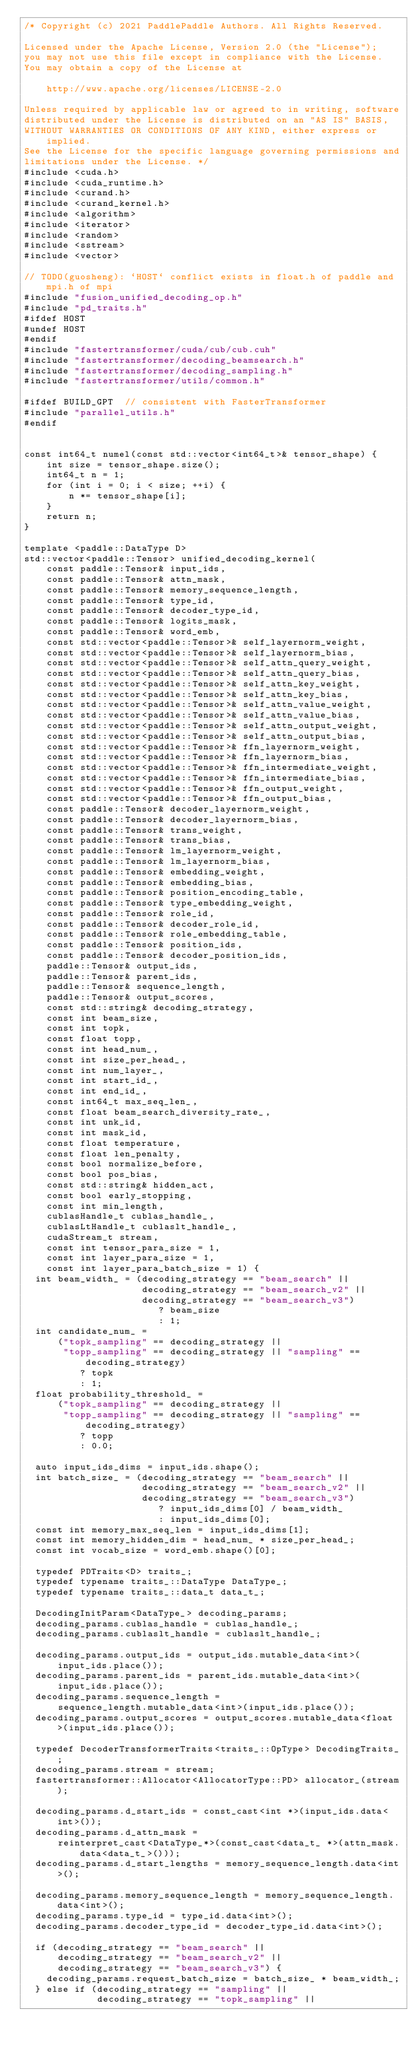<code> <loc_0><loc_0><loc_500><loc_500><_Cuda_>/* Copyright (c) 2021 PaddlePaddle Authors. All Rights Reserved.

Licensed under the Apache License, Version 2.0 (the "License");
you may not use this file except in compliance with the License.
You may obtain a copy of the License at

    http://www.apache.org/licenses/LICENSE-2.0

Unless required by applicable law or agreed to in writing, software
distributed under the License is distributed on an "AS IS" BASIS,
WITHOUT WARRANTIES OR CONDITIONS OF ANY KIND, either express or implied.
See the License for the specific language governing permissions and
limitations under the License. */
#include <cuda.h>
#include <cuda_runtime.h>
#include <curand.h>
#include <curand_kernel.h>
#include <algorithm>
#include <iterator>
#include <random>
#include <sstream>
#include <vector>

// TODO(guosheng): `HOST` conflict exists in float.h of paddle and mpi.h of mpi
#include "fusion_unified_decoding_op.h"
#include "pd_traits.h"
#ifdef HOST
#undef HOST
#endif
#include "fastertransformer/cuda/cub/cub.cuh"
#include "fastertransformer/decoding_beamsearch.h"
#include "fastertransformer/decoding_sampling.h"
#include "fastertransformer/utils/common.h"

#ifdef BUILD_GPT  // consistent with FasterTransformer
#include "parallel_utils.h"
#endif


const int64_t numel(const std::vector<int64_t>& tensor_shape) {
    int size = tensor_shape.size();
    int64_t n = 1;
    for (int i = 0; i < size; ++i) {
        n *= tensor_shape[i];
    }
    return n;
}

template <paddle::DataType D>
std::vector<paddle::Tensor> unified_decoding_kernel(
    const paddle::Tensor& input_ids,
    const paddle::Tensor& attn_mask,
    const paddle::Tensor& memory_sequence_length,
    const paddle::Tensor& type_id,
    const paddle::Tensor& decoder_type_id,
    const paddle::Tensor& logits_mask,
    const paddle::Tensor& word_emb,
    const std::vector<paddle::Tensor>& self_layernorm_weight,
    const std::vector<paddle::Tensor>& self_layernorm_bias,
    const std::vector<paddle::Tensor>& self_attn_query_weight,
    const std::vector<paddle::Tensor>& self_attn_query_bias,
    const std::vector<paddle::Tensor>& self_attn_key_weight,
    const std::vector<paddle::Tensor>& self_attn_key_bias,
    const std::vector<paddle::Tensor>& self_attn_value_weight,
    const std::vector<paddle::Tensor>& self_attn_value_bias,
    const std::vector<paddle::Tensor>& self_attn_output_weight,
    const std::vector<paddle::Tensor>& self_attn_output_bias,
    const std::vector<paddle::Tensor>& ffn_layernorm_weight,
    const std::vector<paddle::Tensor>& ffn_layernorm_bias,
    const std::vector<paddle::Tensor>& ffn_intermediate_weight,
    const std::vector<paddle::Tensor>& ffn_intermediate_bias,
    const std::vector<paddle::Tensor>& ffn_output_weight,
    const std::vector<paddle::Tensor>& ffn_output_bias,
    const paddle::Tensor& decoder_layernorm_weight,
    const paddle::Tensor& decoder_layernorm_bias,
    const paddle::Tensor& trans_weight,
    const paddle::Tensor& trans_bias,
    const paddle::Tensor& lm_layernorm_weight,
    const paddle::Tensor& lm_layernorm_bias,
    const paddle::Tensor& embedding_weight,
    const paddle::Tensor& embedding_bias,
    const paddle::Tensor& position_encoding_table,
    const paddle::Tensor& type_embedding_weight,
    const paddle::Tensor& role_id,
    const paddle::Tensor& decoder_role_id,
    const paddle::Tensor& role_embedding_table,
    const paddle::Tensor& position_ids,
    const paddle::Tensor& decoder_position_ids,
    paddle::Tensor& output_ids,
    paddle::Tensor& parent_ids,
    paddle::Tensor& sequence_length,
    paddle::Tensor& output_scores,
    const std::string& decoding_strategy,
    const int beam_size,
    const int topk,
    const float topp,
    const int head_num_,
    const int size_per_head_,
    const int num_layer_,
    const int start_id_,
    const int end_id_,
    const int64_t max_seq_len_,
    const float beam_search_diversity_rate_,
    const int unk_id,
    const int mask_id,
    const float temperature,
    const float len_penalty,
    const bool normalize_before,
    const bool pos_bias,
    const std::string& hidden_act,
    const bool early_stopping,
    const int min_length,
    cublasHandle_t cublas_handle_,
    cublasLtHandle_t cublaslt_handle_,
    cudaStream_t stream,
    const int tensor_para_size = 1,
    const int layer_para_size = 1,
    const int layer_para_batch_size = 1) {
  int beam_width_ = (decoding_strategy == "beam_search" ||
                     decoding_strategy == "beam_search_v2" ||
                     decoding_strategy == "beam_search_v3")
                        ? beam_size
                        : 1;
  int candidate_num_ =
      ("topk_sampling" == decoding_strategy ||
       "topp_sampling" == decoding_strategy || "sampling" == decoding_strategy)
          ? topk
          : 1;
  float probability_threshold_ =
      ("topk_sampling" == decoding_strategy ||
       "topp_sampling" == decoding_strategy || "sampling" == decoding_strategy)
          ? topp
          : 0.0;

  auto input_ids_dims = input_ids.shape();
  int batch_size_ = (decoding_strategy == "beam_search" ||
                     decoding_strategy == "beam_search_v2" ||
                     decoding_strategy == "beam_search_v3")
                        ? input_ids_dims[0] / beam_width_
                        : input_ids_dims[0];
  const int memory_max_seq_len = input_ids_dims[1];
  const int memory_hidden_dim = head_num_ * size_per_head_;
  const int vocab_size = word_emb.shape()[0];

  typedef PDTraits<D> traits_;
  typedef typename traits_::DataType DataType_;
  typedef typename traits_::data_t data_t_;

  DecodingInitParam<DataType_> decoding_params;
  decoding_params.cublas_handle = cublas_handle_;
  decoding_params.cublaslt_handle = cublaslt_handle_;

  decoding_params.output_ids = output_ids.mutable_data<int>(input_ids.place());
  decoding_params.parent_ids = parent_ids.mutable_data<int>(input_ids.place());
  decoding_params.sequence_length =
      sequence_length.mutable_data<int>(input_ids.place());
  decoding_params.output_scores = output_scores.mutable_data<float>(input_ids.place());

  typedef DecoderTransformerTraits<traits_::OpType> DecodingTraits_;
  decoding_params.stream = stream;
  fastertransformer::Allocator<AllocatorType::PD> allocator_(stream);

  decoding_params.d_start_ids = const_cast<int *>(input_ids.data<int>());
  decoding_params.d_attn_mask =
      reinterpret_cast<DataType_*>(const_cast<data_t_ *>(attn_mask.data<data_t_>()));
  decoding_params.d_start_lengths = memory_sequence_length.data<int>();

  decoding_params.memory_sequence_length = memory_sequence_length.data<int>();
  decoding_params.type_id = type_id.data<int>();
  decoding_params.decoder_type_id = decoder_type_id.data<int>();

  if (decoding_strategy == "beam_search" ||
      decoding_strategy == "beam_search_v2" ||
      decoding_strategy == "beam_search_v3") {
    decoding_params.request_batch_size = batch_size_ * beam_width_;
  } else if (decoding_strategy == "sampling" ||
             decoding_strategy == "topk_sampling" ||</code> 